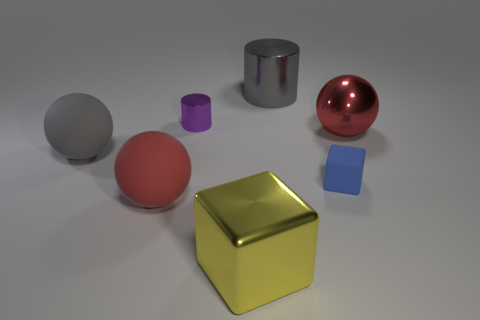How many other small rubber blocks have the same color as the small block?
Your answer should be compact. 0. Is there any other thing that has the same material as the large gray cylinder?
Provide a short and direct response. Yes. Are there fewer red spheres that are to the left of the purple shiny object than yellow metallic balls?
Offer a very short reply. No. There is a small thing that is in front of the large ball behind the large gray matte ball; what color is it?
Offer a very short reply. Blue. How big is the red object to the right of the big object behind the big red thing that is right of the blue cube?
Offer a very short reply. Large. Is the number of small purple shiny cylinders that are left of the small shiny cylinder less than the number of big gray spheres on the right side of the big yellow object?
Provide a short and direct response. No. How many small blue things are the same material as the gray sphere?
Your answer should be compact. 1. There is a large red object that is on the right side of the gray object right of the gray matte sphere; is there a tiny block behind it?
Provide a succinct answer. No. What is the shape of the purple object that is made of the same material as the large cylinder?
Ensure brevity in your answer.  Cylinder. Are there more small gray matte spheres than large metallic spheres?
Provide a succinct answer. No. 